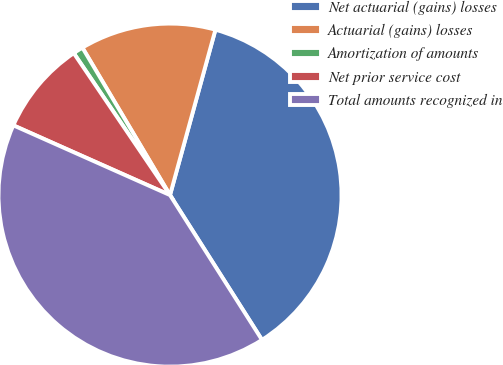<chart> <loc_0><loc_0><loc_500><loc_500><pie_chart><fcel>Net actuarial (gains) losses<fcel>Actuarial (gains) losses<fcel>Amortization of amounts<fcel>Net prior service cost<fcel>Total amounts recognized in<nl><fcel>36.73%<fcel>12.8%<fcel>0.95%<fcel>8.85%<fcel>40.68%<nl></chart> 